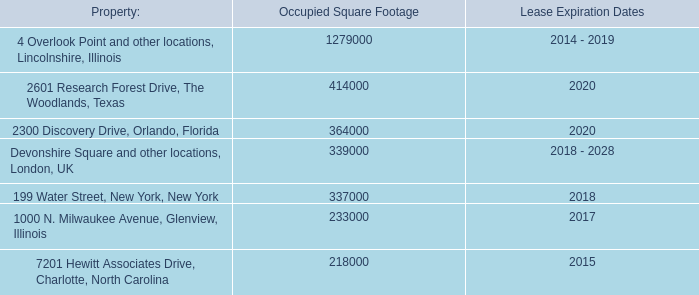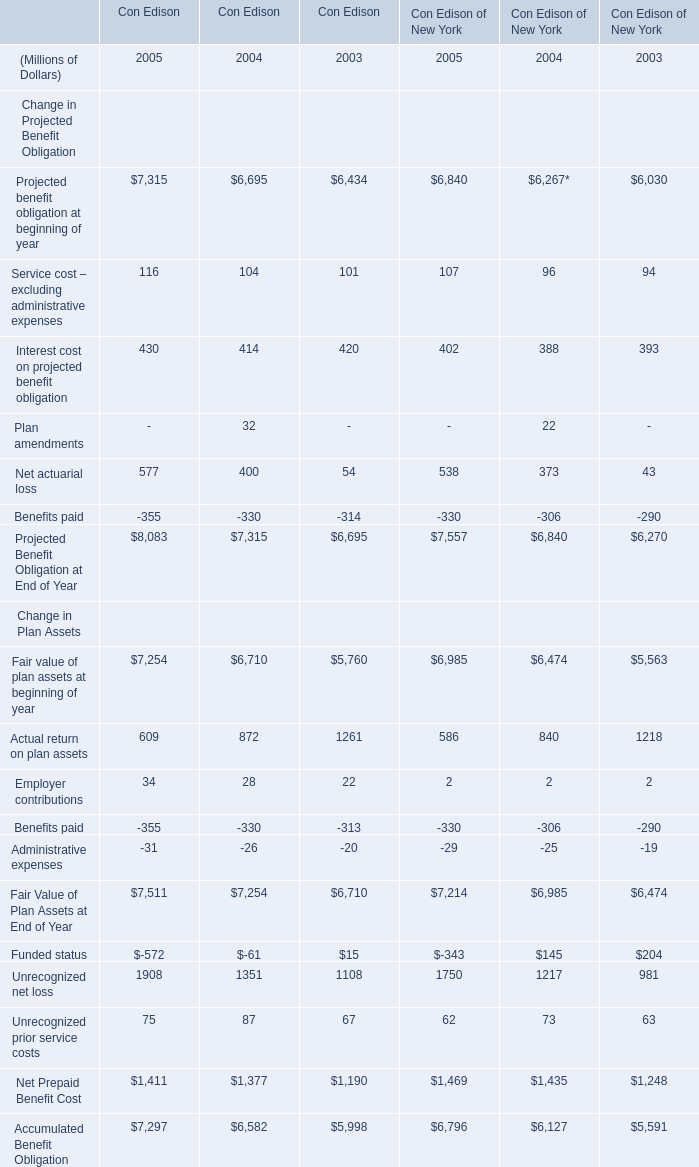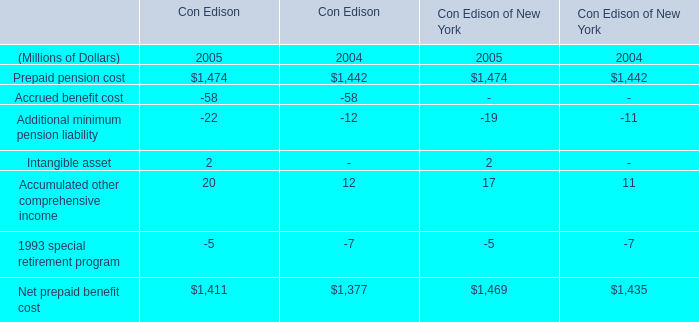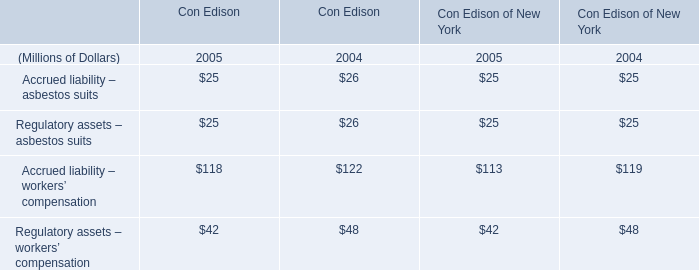How long does Projected Benefit Obligation at End of Year keep growing? (in year) 
Answer: 3. 